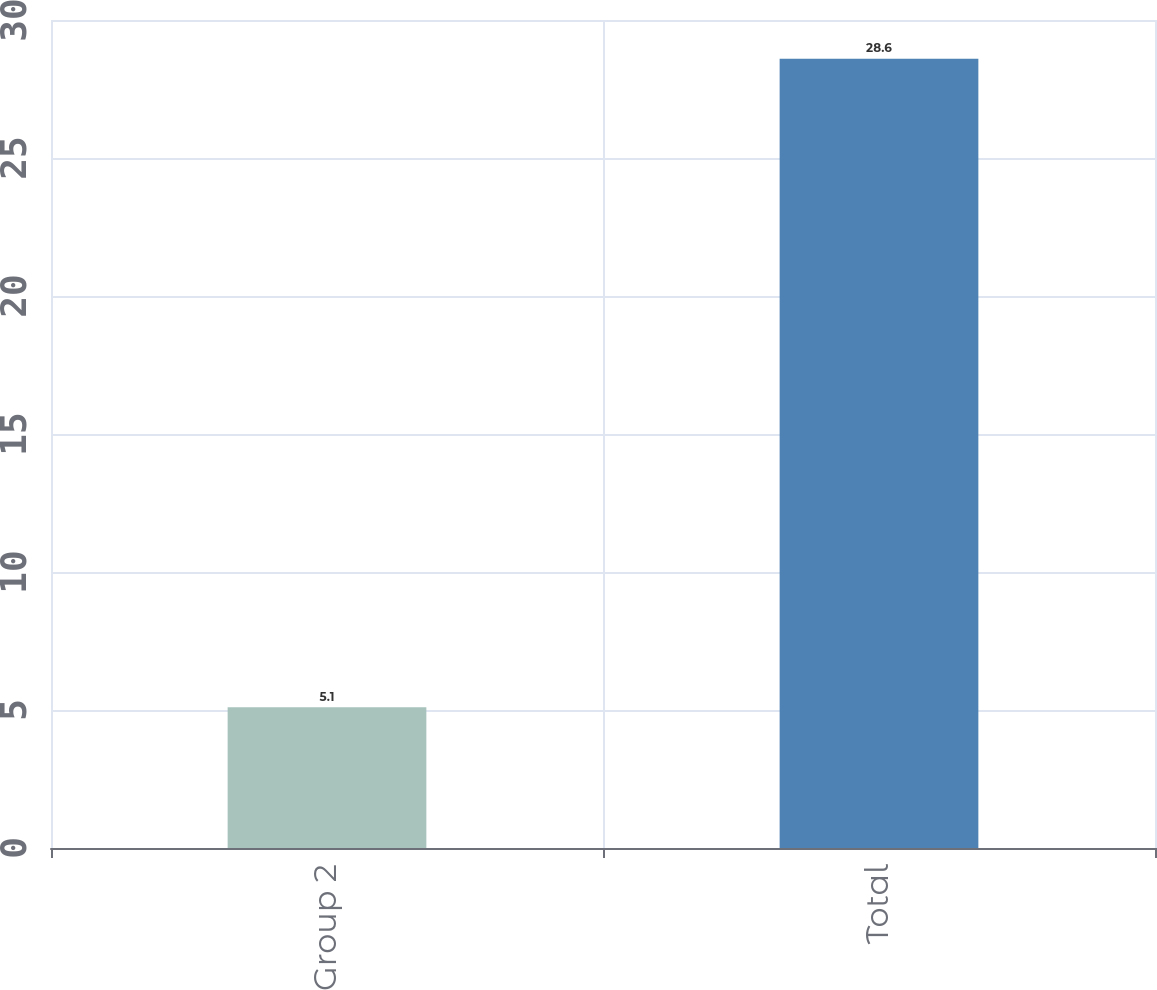Convert chart. <chart><loc_0><loc_0><loc_500><loc_500><bar_chart><fcel>Group 2<fcel>Total<nl><fcel>5.1<fcel>28.6<nl></chart> 